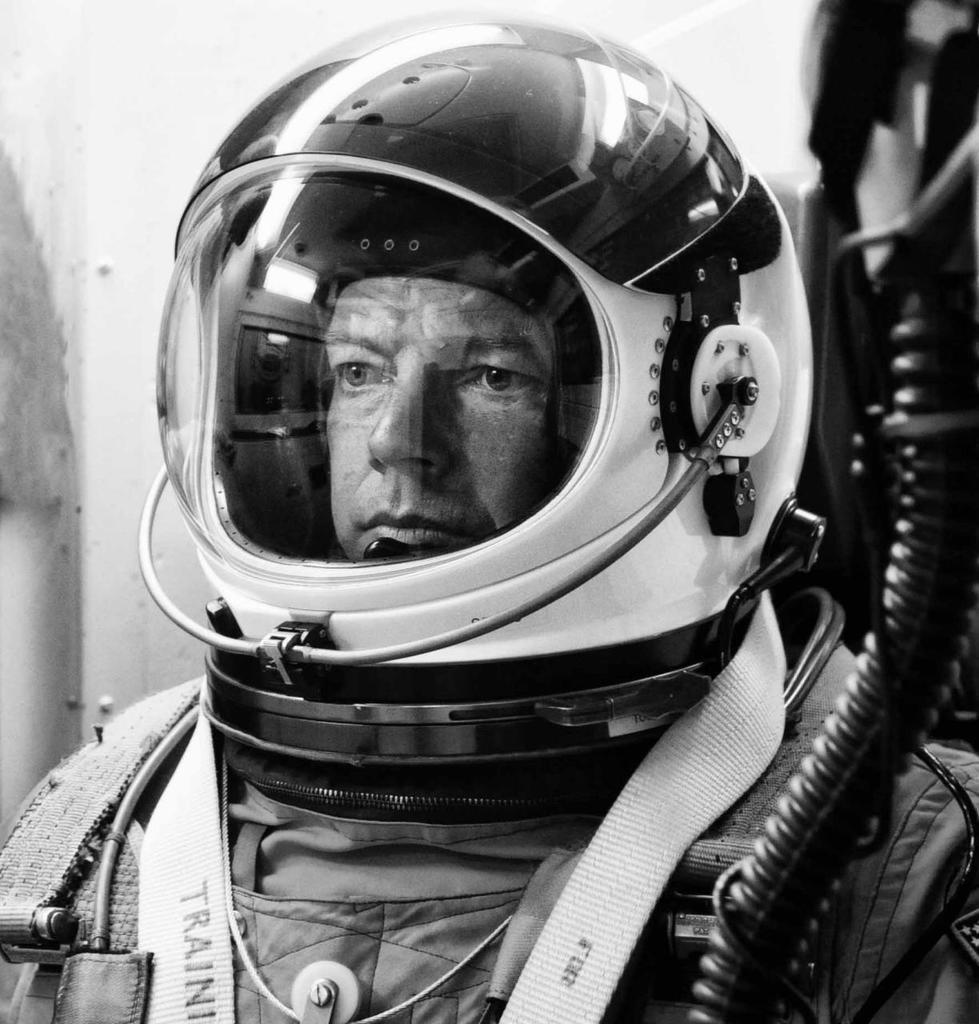What is the color scheme of the image? The image is black and white. Can you describe the person in the image? The person in the image is wearing a space suit. What can be observed about the background of the image? The background of the image is slightly blurred. Can you tell me how many robins are perched on the person's helmet in the image? There are no robins present in the image; it features a person wearing a space suit in a black and white setting. Is there any popcorn visible in the image? There is no popcorn present in the image. 